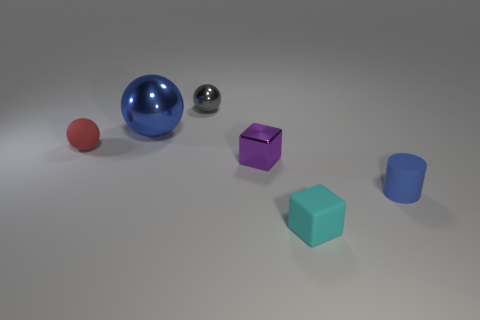There is a gray shiny object; what number of tiny cyan rubber cubes are right of it?
Your answer should be very brief. 1. What color is the tiny shiny thing that is the same shape as the large metal thing?
Offer a very short reply. Gray. How many shiny objects are tiny gray balls or small purple objects?
Your answer should be compact. 2. Is there a red sphere that is behind the rubber thing in front of the blue thing on the right side of the tiny cyan matte cube?
Offer a terse response. Yes. The small matte sphere is what color?
Ensure brevity in your answer.  Red. Do the big blue object behind the rubber cube and the purple metallic object have the same shape?
Your answer should be very brief. No. What number of things are either tiny cylinders or small things that are behind the cyan matte cube?
Your answer should be compact. 4. Do the blue thing that is to the left of the tiny gray thing and the blue cylinder have the same material?
Offer a terse response. No. Is there anything else that has the same size as the gray metallic object?
Provide a succinct answer. Yes. The small red object in front of the small ball that is to the right of the large ball is made of what material?
Offer a very short reply. Rubber. 